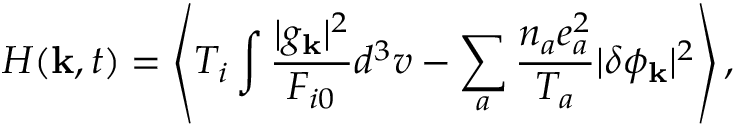Convert formula to latex. <formula><loc_0><loc_0><loc_500><loc_500>H ( { k } , t ) = \left \langle T _ { i } \int \frac { | g _ { k } | ^ { 2 } } { F _ { i 0 } } d ^ { 3 } v - \sum _ { a } \frac { n _ { a } e _ { a } ^ { 2 } } { T _ { a } } | \delta \phi _ { k } | ^ { 2 } \right \rangle ,</formula> 